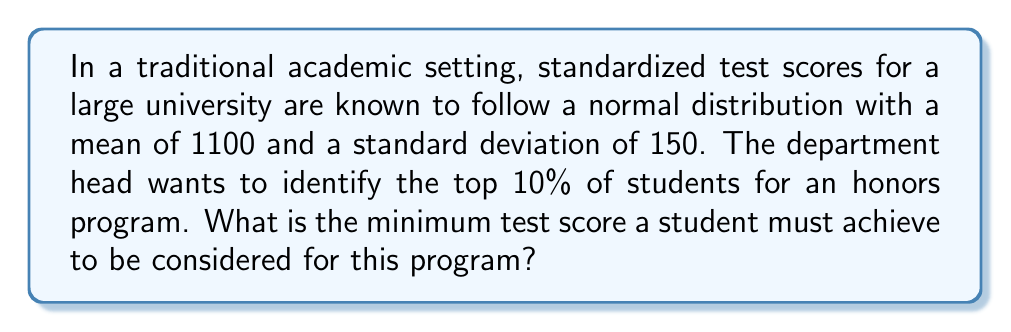Solve this math problem. To solve this problem, we need to use the properties of the normal distribution and the z-score formula. We'll follow these steps:

1. Identify the given information:
   - Mean (μ) = 1100
   - Standard deviation (σ) = 150
   - We need to find the score at the 90th percentile (top 10%)

2. Find the z-score corresponding to the 90th percentile:
   - Using a standard normal distribution table or calculator, we find that the z-score for the 90th percentile is approximately 1.28.

3. Use the z-score formula to find the required test score:
   $$z = \frac{x - μ}{σ}$$
   where x is the score we're looking for.

4. Rearrange the formula to solve for x:
   $$x = μ + (z × σ)$$

5. Substitute the values:
   $$x = 1100 + (1.28 × 150)$$

6. Calculate the result:
   $$x = 1100 + 192 = 1292$$

Therefore, the minimum test score a student must achieve to be in the top 10% is 1292.
Answer: 1292 